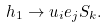<formula> <loc_0><loc_0><loc_500><loc_500>h _ { 1 } \to u _ { i } e _ { j } S _ { k } .</formula> 